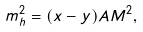Convert formula to latex. <formula><loc_0><loc_0><loc_500><loc_500>m _ { h } ^ { 2 } = ( x - y ) A M ^ { 2 } ,</formula> 